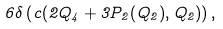<formula> <loc_0><loc_0><loc_500><loc_500>6 \delta \left ( c ( 2 Q _ { 4 } + 3 P _ { 2 } ( Q _ { 2 } ) , Q _ { 2 } ) \right ) ,</formula> 